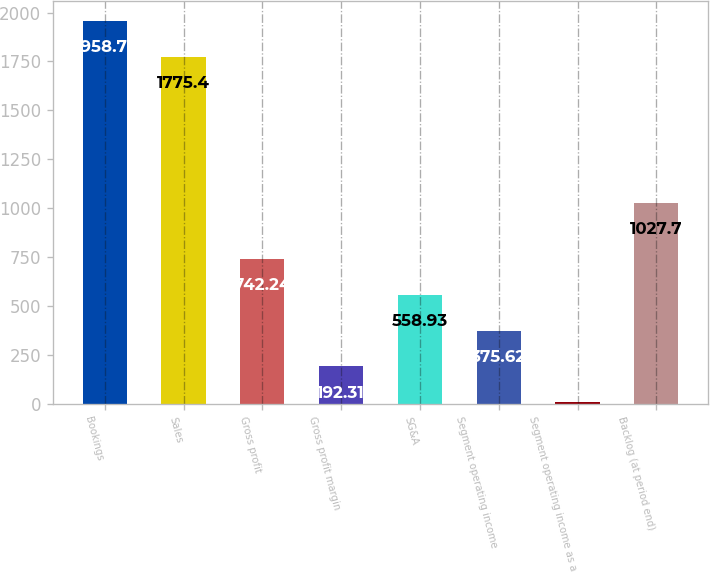Convert chart. <chart><loc_0><loc_0><loc_500><loc_500><bar_chart><fcel>Bookings<fcel>Sales<fcel>Gross profit<fcel>Gross profit margin<fcel>SG&A<fcel>Segment operating income<fcel>Segment operating income as a<fcel>Backlog (at period end)<nl><fcel>1958.71<fcel>1775.4<fcel>742.24<fcel>192.31<fcel>558.93<fcel>375.62<fcel>9<fcel>1027.7<nl></chart> 